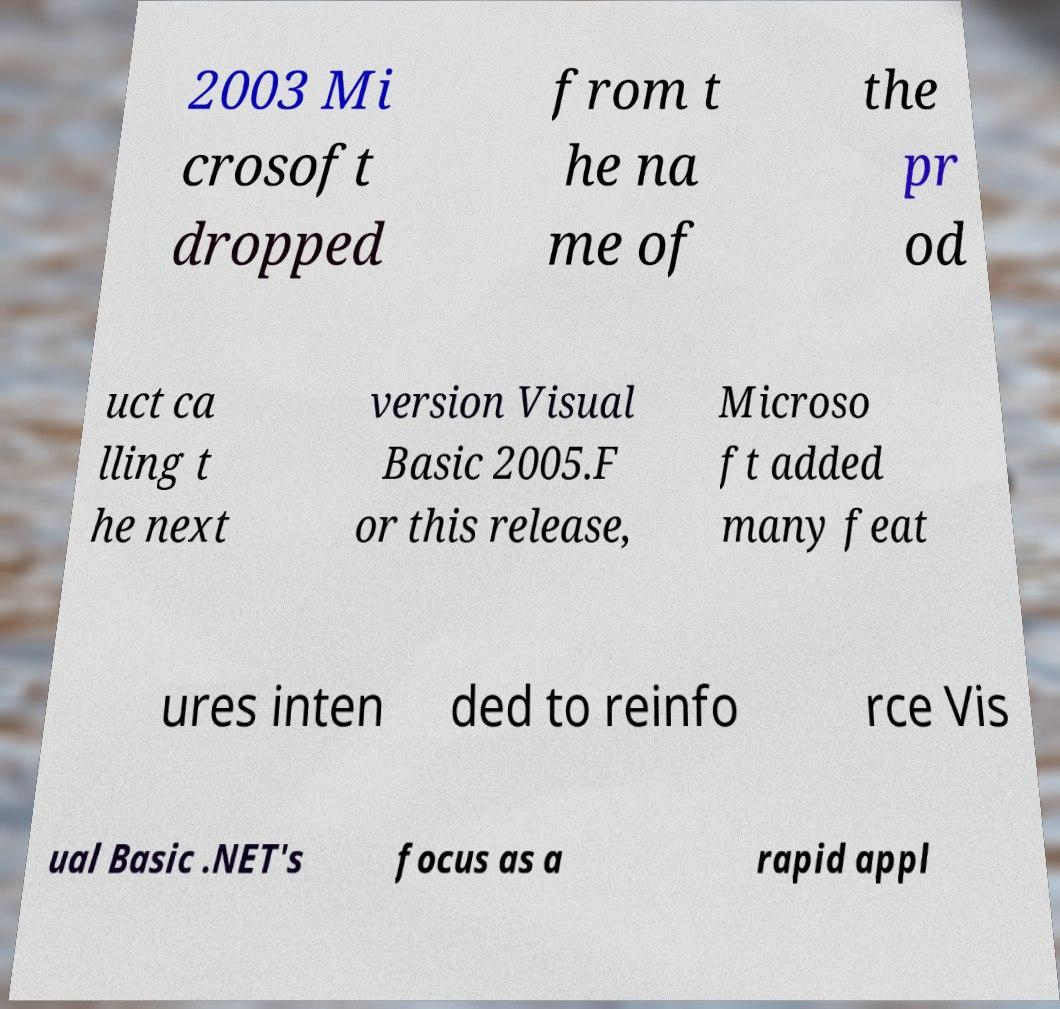For documentation purposes, I need the text within this image transcribed. Could you provide that? 2003 Mi crosoft dropped from t he na me of the pr od uct ca lling t he next version Visual Basic 2005.F or this release, Microso ft added many feat ures inten ded to reinfo rce Vis ual Basic .NET's focus as a rapid appl 